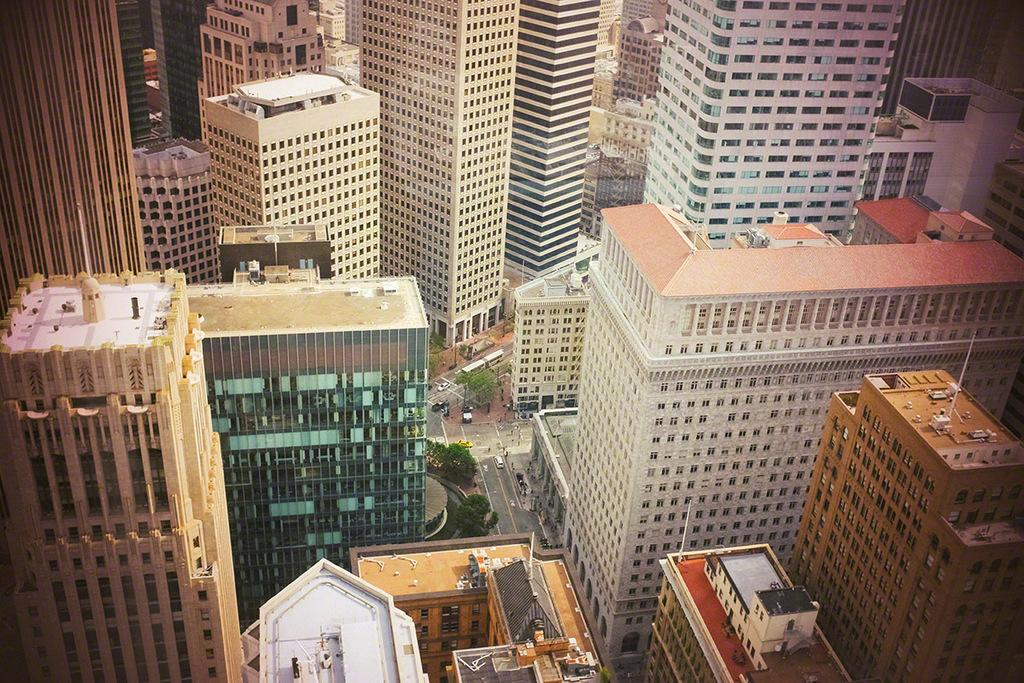What type of view is shown in the image? The image is an aerial view. What can be seen in the image from this perspective? There are many buildings and roads visible in the image. Are there any vehicles on the roads? Yes, vehicles are visible on the roads. What else can be seen in the image besides buildings and roads? There are trees in the image. Where is the basin located in the image? There is no basin present in the image. What type of bubble can be seen floating above the buildings? There are no bubbles visible in the image. 